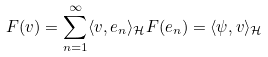Convert formula to latex. <formula><loc_0><loc_0><loc_500><loc_500>F ( v ) = \sum _ { n = 1 } ^ { \infty } \langle v , e _ { n } \rangle _ { \mathcal { H } } F ( e _ { n } ) = \langle \psi , v \rangle _ { \mathcal { H } }</formula> 